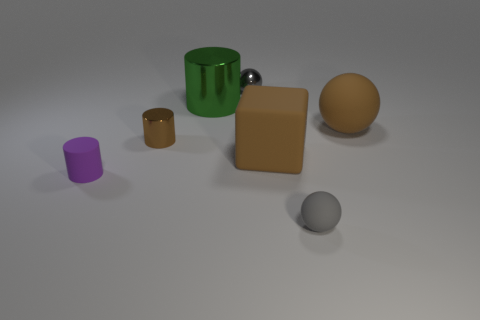Add 3 tiny gray metallic things. How many objects exist? 10 Subtract all blocks. How many objects are left? 6 Subtract all matte spheres. Subtract all small balls. How many objects are left? 3 Add 5 small purple matte things. How many small purple matte things are left? 6 Add 5 small purple objects. How many small purple objects exist? 6 Subtract 0 purple cubes. How many objects are left? 7 